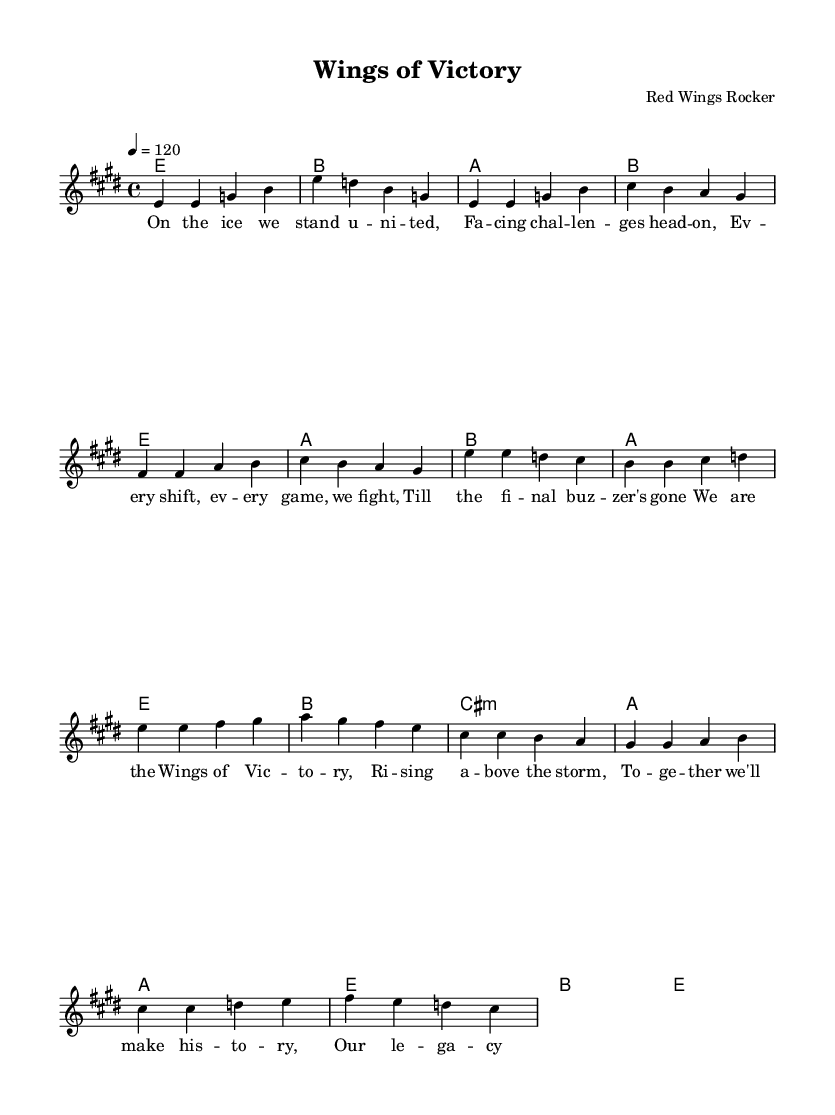What is the key signature of this music? The key signature is E major, which has four sharps: F sharp, C sharp, G sharp, and D sharp.
Answer: E major What is the time signature of this piece? The time signature is 4/4, indicating there are four beats per measure and a quarter note gets one beat.
Answer: 4/4 What is the tempo marking for this song? The tempo marking is 120 beats per minute, indicating a moderately fast pace for the music.
Answer: 120 How many verses are included in the lyrics? There is one verse included in the lyrics before the chorus, as indicated in the structure of the song.
Answer: One verse What chord follows the intro section? The chord that follows the intro section is E major, which continues the musical progression through the verse.
Answer: E How many measures are in the chorus section? The chorus section consists of four measures, as indicated in the musical notation for the lyrics.
Answer: Four measures What do the lyrics of the bridge emphasize? The lyrics of the bridge emphasize perseverance and unity, reflecting the theme of overcoming adversity.
Answer: Perseverance and unity 